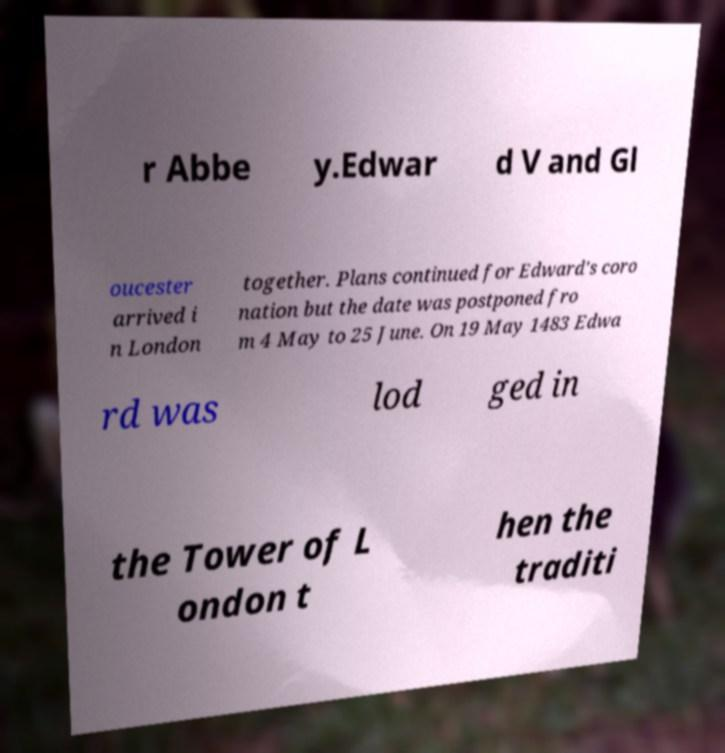For documentation purposes, I need the text within this image transcribed. Could you provide that? r Abbe y.Edwar d V and Gl oucester arrived i n London together. Plans continued for Edward's coro nation but the date was postponed fro m 4 May to 25 June. On 19 May 1483 Edwa rd was lod ged in the Tower of L ondon t hen the traditi 